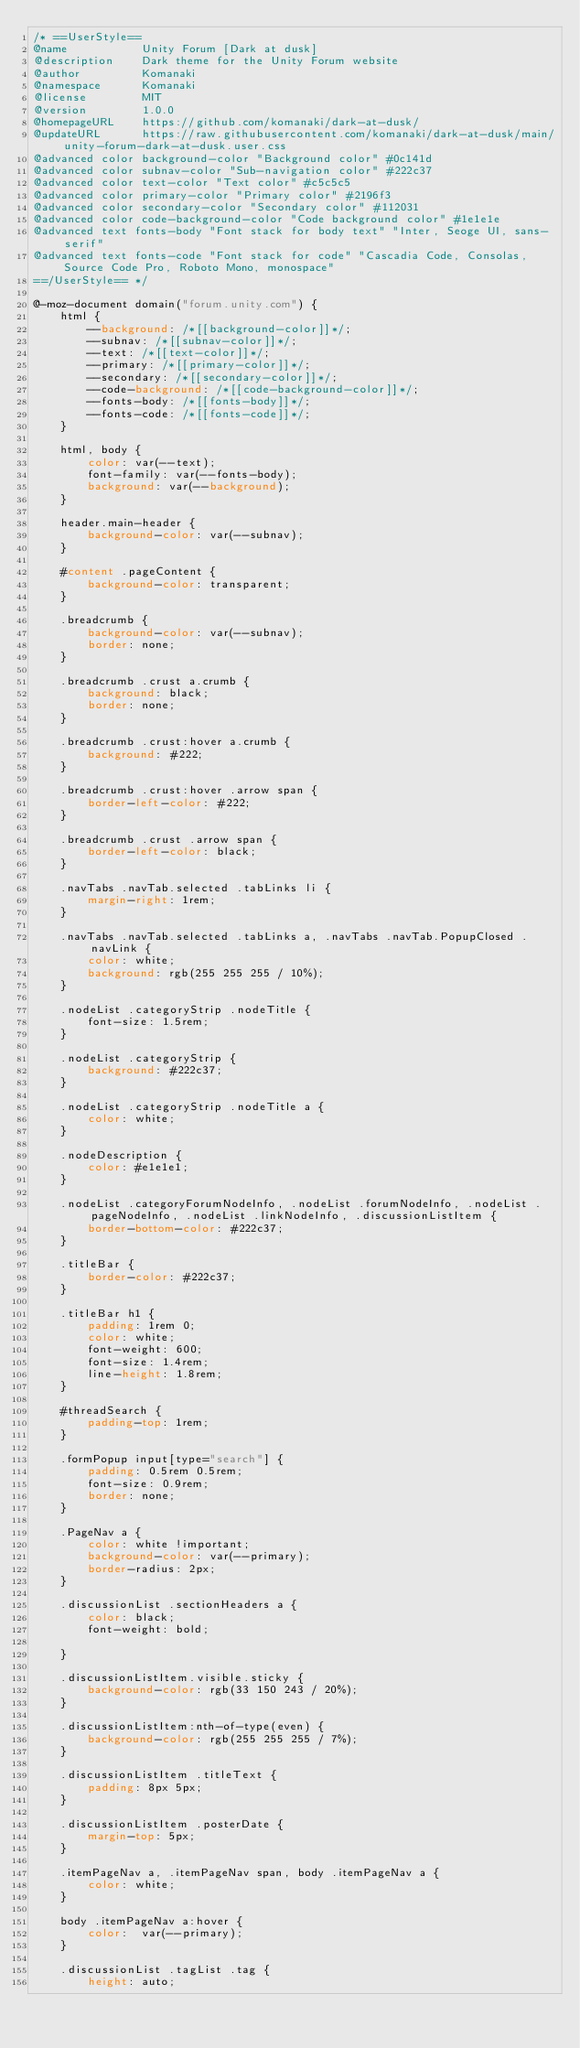Convert code to text. <code><loc_0><loc_0><loc_500><loc_500><_CSS_>/* ==UserStyle==
@name           Unity Forum [Dark at dusk]
@description    Dark theme for the Unity Forum website
@author         Komanaki
@namespace      Komanaki
@license        MIT
@version        1.0.0
@homepageURL    https://github.com/komanaki/dark-at-dusk/
@updateURL      https://raw.githubusercontent.com/komanaki/dark-at-dusk/main/unity-forum-dark-at-dusk.user.css
@advanced color background-color "Background color" #0c141d
@advanced color subnav-color "Sub-navigation color" #222c37
@advanced color text-color "Text color" #c5c5c5
@advanced color primary-color "Primary color" #2196f3
@advanced color secondary-color "Secondary color" #112031
@advanced color code-background-color "Code background color" #1e1e1e
@advanced text fonts-body "Font stack for body text" "Inter, Seoge UI, sans-serif"
@advanced text fonts-code "Font stack for code" "Cascadia Code, Consolas, Source Code Pro, Roboto Mono, monospace"
==/UserStyle== */

@-moz-document domain("forum.unity.com") {
    html {
        --background: /*[[background-color]]*/;
        --subnav: /*[[subnav-color]]*/;
        --text: /*[[text-color]]*/;
        --primary: /*[[primary-color]]*/;
        --secondary: /*[[secondary-color]]*/;
        --code-background: /*[[code-background-color]]*/;
        --fonts-body: /*[[fonts-body]]*/;
        --fonts-code: /*[[fonts-code]]*/;
    }

    html, body {
        color: var(--text);
        font-family: var(--fonts-body);
        background: var(--background);
    }

    header.main-header {
        background-color: var(--subnav);
    }

    #content .pageContent {
        background-color: transparent;
    }

    .breadcrumb {
        background-color: var(--subnav);
        border: none;
    }

    .breadcrumb .crust a.crumb {
        background: black;
        border: none;
    }

    .breadcrumb .crust:hover a.crumb {
        background: #222;
    }

    .breadcrumb .crust:hover .arrow span {
        border-left-color: #222;
    }

    .breadcrumb .crust .arrow span {
        border-left-color: black;
    }
    
    .navTabs .navTab.selected .tabLinks li {
        margin-right: 1rem;
    }

    .navTabs .navTab.selected .tabLinks a, .navTabs .navTab.PopupClosed .navLink {
        color: white;
        background: rgb(255 255 255 / 10%);
    }

    .nodeList .categoryStrip .nodeTitle {
        font-size: 1.5rem;
    }

    .nodeList .categoryStrip {
        background: #222c37;
    }

    .nodeList .categoryStrip .nodeTitle a {
        color: white;
    }

    .nodeDescription {
        color: #e1e1e1;
    }

    .nodeList .categoryForumNodeInfo, .nodeList .forumNodeInfo, .nodeList .pageNodeInfo, .nodeList .linkNodeInfo, .discussionListItem {
        border-bottom-color: #222c37;
    }
    
    .titleBar {
        border-color: #222c37;
    }

    .titleBar h1 {
        padding: 1rem 0;
        color: white;
        font-weight: 600;
        font-size: 1.4rem;
        line-height: 1.8rem;
    }
    
    #threadSearch {
        padding-top: 1rem;
    }
    
    .formPopup input[type="search"] {
        padding: 0.5rem 0.5rem;
        font-size: 0.9rem;
        border: none;
    }

    .PageNav a {
        color: white !important;
        background-color: var(--primary);
        border-radius: 2px;
    }

    .discussionList .sectionHeaders a {
        color: black;
        font-weight: bold;

    }

    .discussionListItem.visible.sticky {
        background-color: rgb(33 150 243 / 20%);
    }

    .discussionListItem:nth-of-type(even) {
        background-color: rgb(255 255 255 / 7%);
    }

    .discussionListItem .titleText {
        padding: 8px 5px;
    }

    .discussionListItem .posterDate {
        margin-top: 5px;
    }

    .itemPageNav a, .itemPageNav span, body .itemPageNav a {
        color: white;
    }

    body .itemPageNav a:hover {
        color:  var(--primary);
    }

    .discussionList .tagList .tag {
        height: auto;</code> 